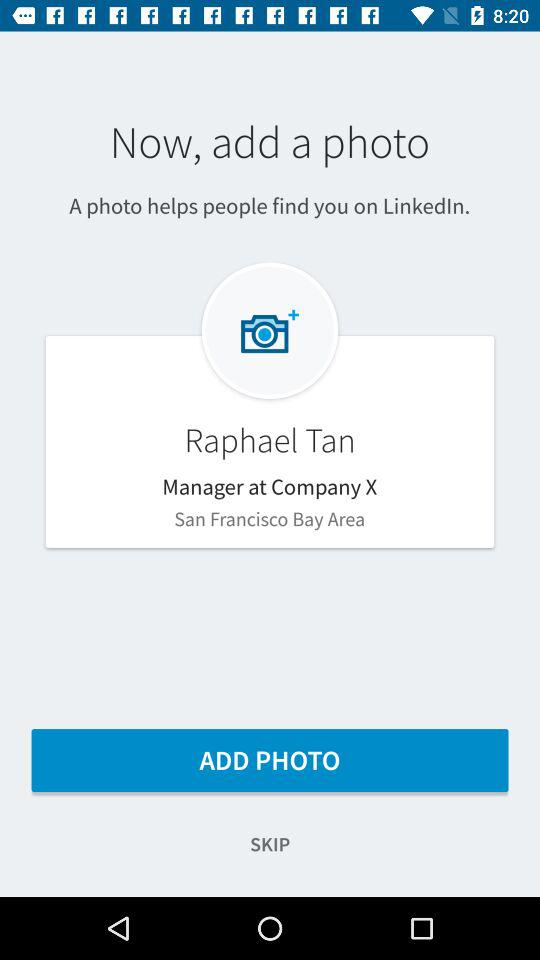What is the user name? The user name is Raphael Tan. 